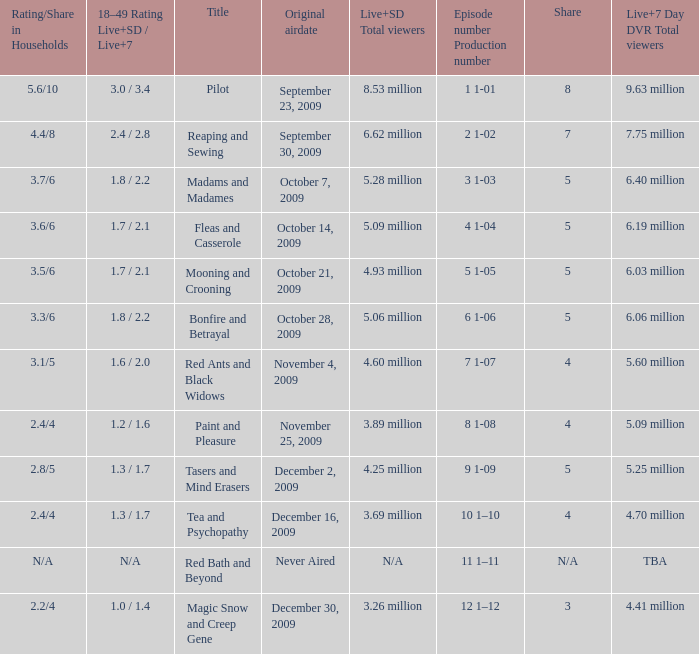When did the episode that had 5.09 million total viewers (both Live and SD types) first air? October 14, 2009. 